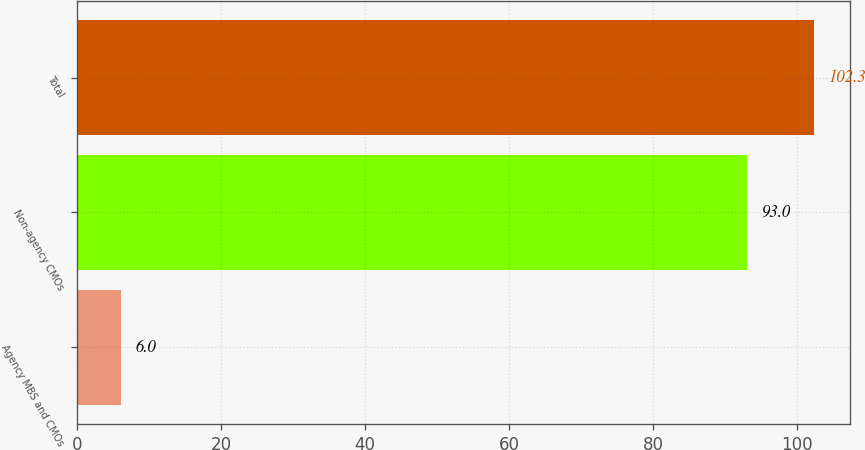<chart> <loc_0><loc_0><loc_500><loc_500><bar_chart><fcel>Agency MBS and CMOs<fcel>Non-agency CMOs<fcel>Total<nl><fcel>6<fcel>93<fcel>102.3<nl></chart> 